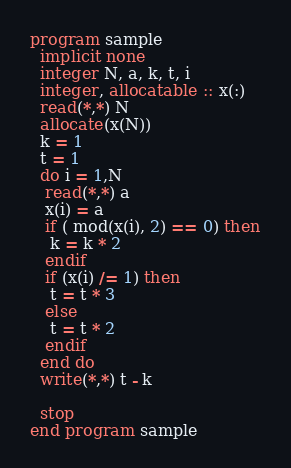<code> <loc_0><loc_0><loc_500><loc_500><_FORTRAN_>program sample
  implicit none
  integer N, a, k, t, i
  integer, allocatable :: x(:)
  read(*,*) N
  allocate(x(N))
  k = 1
  t = 1
  do i = 1,N
   read(*,*) a
   x(i) = a
   if ( mod(x(i), 2) == 0) then
    k = k * 2
   endif
   if (x(i) /= 1) then
    t = t * 3
   else
    t = t * 2
   endif
  end do
  write(*,*) t - k
  
  stop
end program sample </code> 